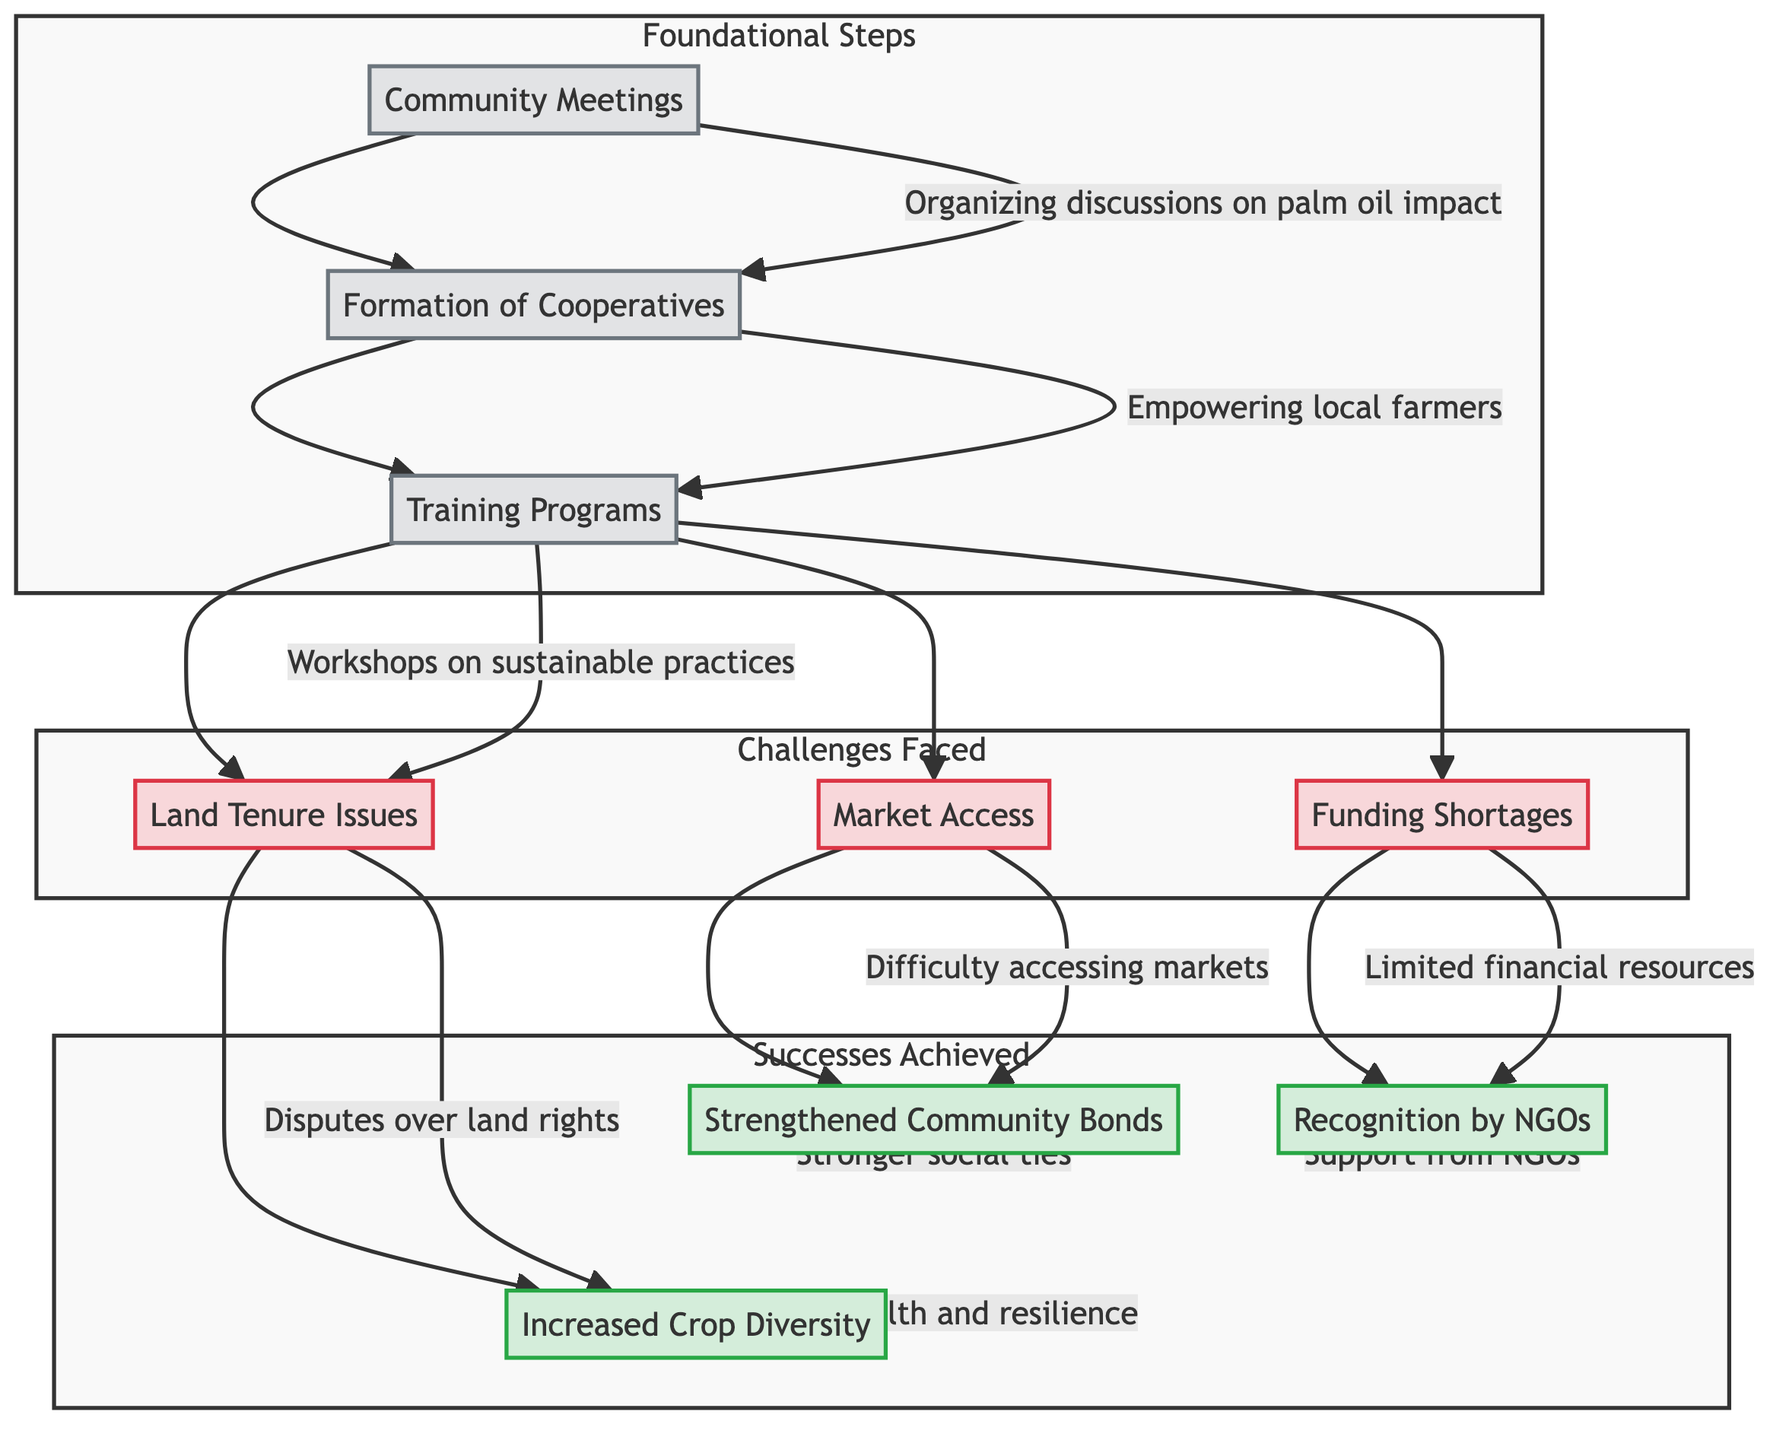What are the foundational steps in the diagram? The diagram lists three foundational steps: Community Meetings, Formation of Cooperatives, and Training Programs. You can find this information under the "Foundational Steps" subgraph.
Answer: Community Meetings, Formation of Cooperatives, Training Programs How many challenges are faced according to the diagram? The diagram displays three challenges faced: Land Tenure Issues, Market Access, and Funding Shortages. All are listed in the "Challenges Faced" section.
Answer: 3 Which success is directly linked to Land Tenure Issues? Trace the connection from the "Challenges Faced" section where Land Tenure Issues leads to the success of Increased Crop Diversity. This relationship indicates that tackling land tenure disputes has resulted in this specific success.
Answer: Increased Crop Diversity What follows the Training Programs step? From the flowchart, after Training Programs, there are connections leading out to three challenges: Land Tenure Issues, Market Access, and Funding Shortages. Therefore, these challenges follow the Training Programs step.
Answer: Land Tenure Issues, Market Access, Funding Shortages Which success is achieved due to difficulties in accessing markets? The diagram indicates that Market Access as a challenge leads to the success of Strengthened Community Bonds. This means that despite the difficulty in market access, the success achieved is related to strengthening community ties.
Answer: Strengthened Community Bonds What is the primary purpose of the Community Meetings step? According to the description provided in the diagram, the purpose of Community Meetings is to "Organizing discussions to raise awareness about the impact of palm oil plantations." This statement captures the essence of this foundational step.
Answer: Raise awareness about the impact of palm oil plantations What is the relationship between Funding Shortages and the successes achieved? Funding Shortages as a challenge leads to the success Recognition by NGOs. This relationship shows that even with funding issues, gaining recognition from NGOs is an outcome of the efforts made by the community.
Answer: Recognition by NGOs Name one success achieved in the community-led initiatives. The diagram lists three successes; therefore, you can simply name any of them such as Increased Crop Diversity, Strengthened Community Bonds, or Recognition by NGOs. These are directly stated in the "Successes Achieved" section.
Answer: Increased Crop Diversity How do the challenges faced impact the successes achieved? The challenges of Land Tenure Issues, Market Access, and Funding Shortages each link to specific successes in the diagram. Thus, addressing these challenges is necessary for achieving the corresponding successes. The intertwining illustrates this cyclical relationship.
Answer: Each challenge leads to a specific success 